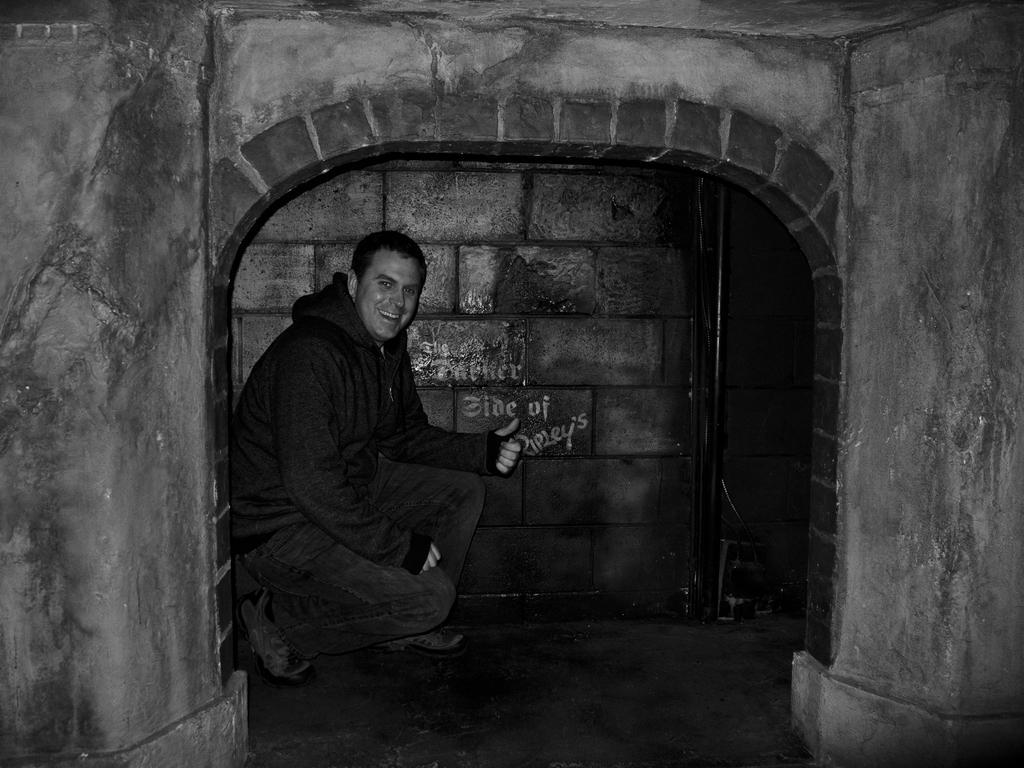Can you describe this image briefly? This image is a black and white image. In this image there is a den with walls. In the middle of the image a man is sitting in the den with a smiling face. 